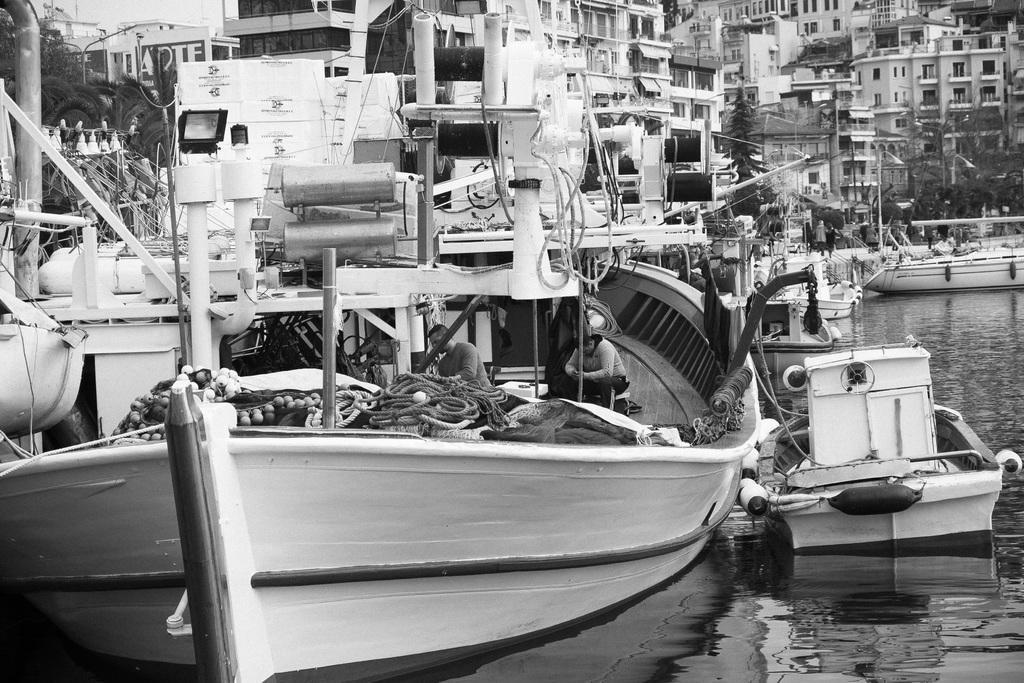How would you summarize this image in a sentence or two? In this image there are buildings truncated towards the top of the image, there are buildings truncated towards the right of the image, there are trees truncated towards the right of the image, there are trees truncated towards the left of the image, there is a pole truncated towards the top of the image, there are boats, there is light, there are objects in the boat, there are persons in the boat, there is water truncated towards the right of the image, there is boat truncated towards the left of the image. 